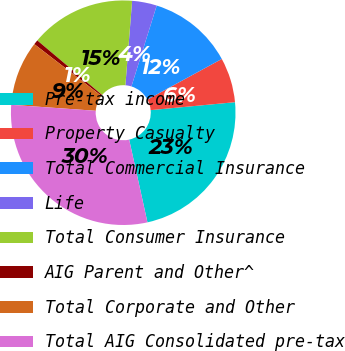Convert chart to OTSL. <chart><loc_0><loc_0><loc_500><loc_500><pie_chart><fcel>Pre-tax income<fcel>Property Casualty<fcel>Total Commercial Insurance<fcel>Life<fcel>Total Consumer Insurance<fcel>AIG Parent and Other^<fcel>Total Corporate and Other<fcel>Total AIG Consolidated pre-tax<nl><fcel>23.03%<fcel>6.45%<fcel>12.23%<fcel>3.56%<fcel>15.13%<fcel>0.67%<fcel>9.34%<fcel>29.58%<nl></chart> 